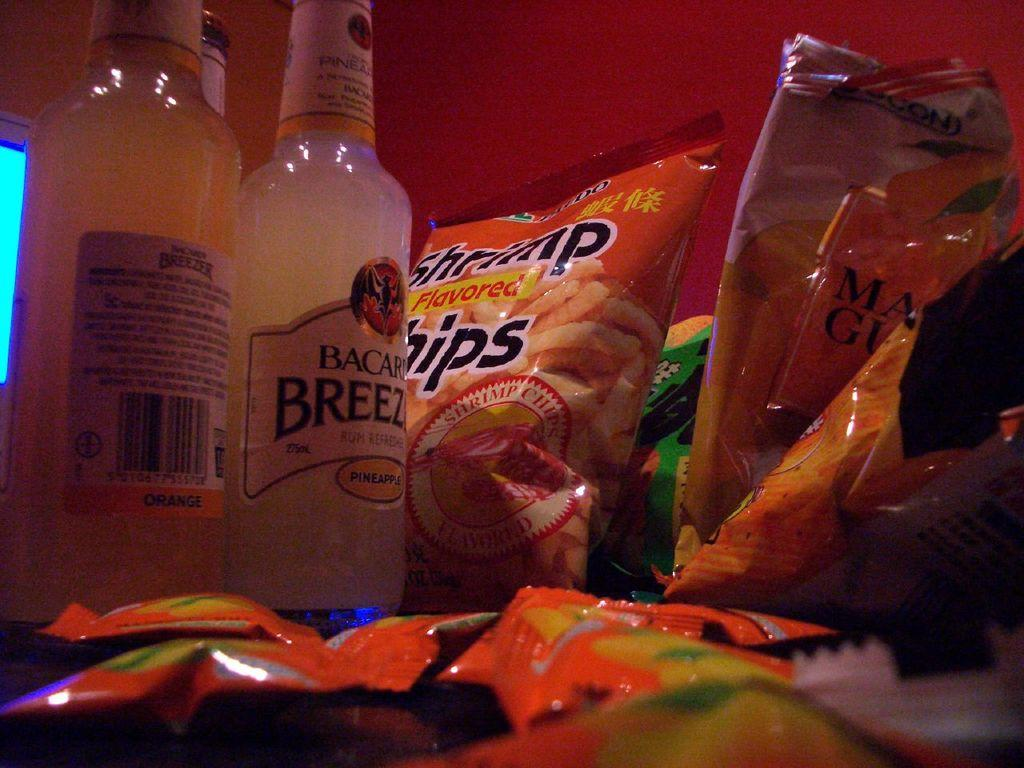<image>
Create a compact narrative representing the image presented. A couple of bottles of Bacardi Breeze next to bags of Shrimp Flavored Chips. 